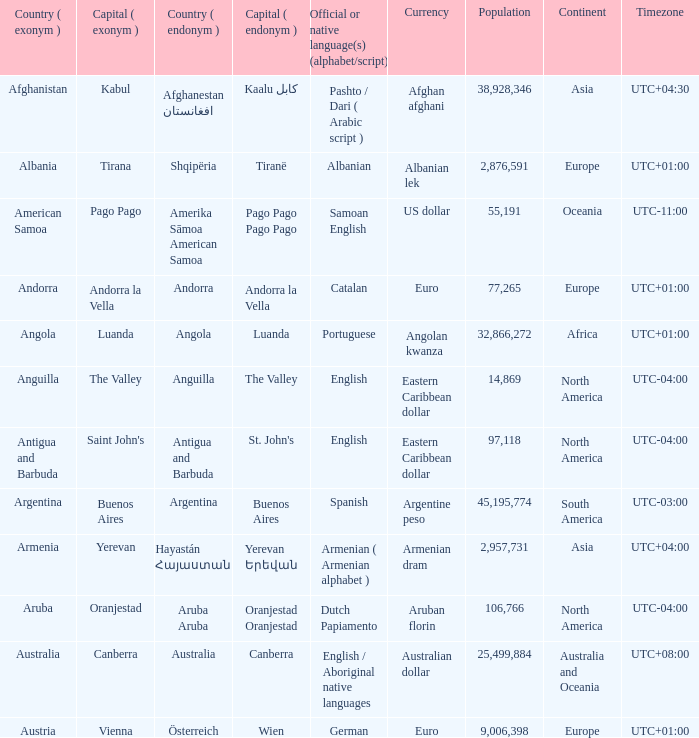What is the local name given to the city of Canberra? Canberra. 